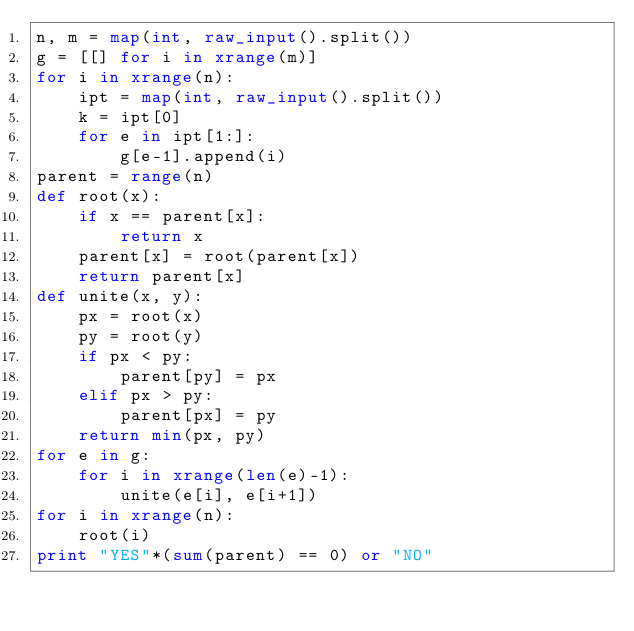<code> <loc_0><loc_0><loc_500><loc_500><_Python_>n, m = map(int, raw_input().split())
g = [[] for i in xrange(m)]
for i in xrange(n):
    ipt = map(int, raw_input().split())
    k = ipt[0]
    for e in ipt[1:]:
        g[e-1].append(i)
parent = range(n)
def root(x):
    if x == parent[x]:
        return x
    parent[x] = root(parent[x])
    return parent[x]
def unite(x, y):
    px = root(x)
    py = root(y)
    if px < py:
        parent[py] = px
    elif px > py:
        parent[px] = py
    return min(px, py)
for e in g:
    for i in xrange(len(e)-1):
        unite(e[i], e[i+1])
for i in xrange(n):
    root(i)
print "YES"*(sum(parent) == 0) or "NO"
</code> 